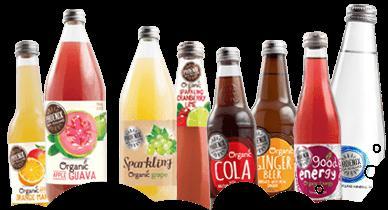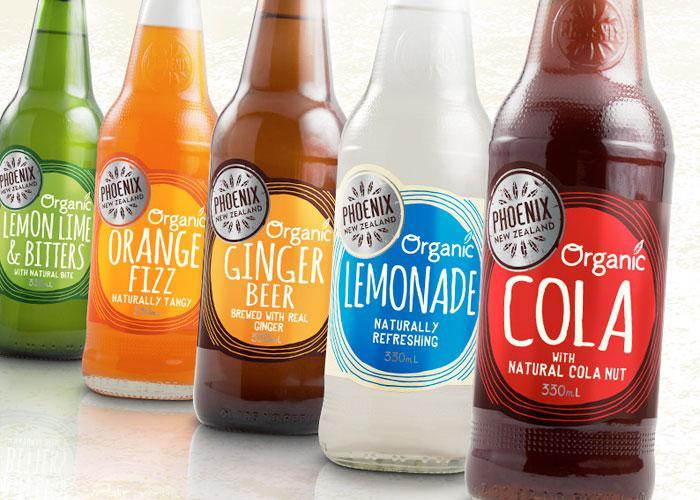The first image is the image on the left, the second image is the image on the right. Assess this claim about the two images: "There are more bottles in the image on the left.". Correct or not? Answer yes or no. Yes. The first image is the image on the left, the second image is the image on the right. Evaluate the accuracy of this statement regarding the images: "One image contains exactly four bottles with various colored circle shapes on each label, and the other image contains no more than four bottles with colorful imagery on their labels.". Is it true? Answer yes or no. No. 